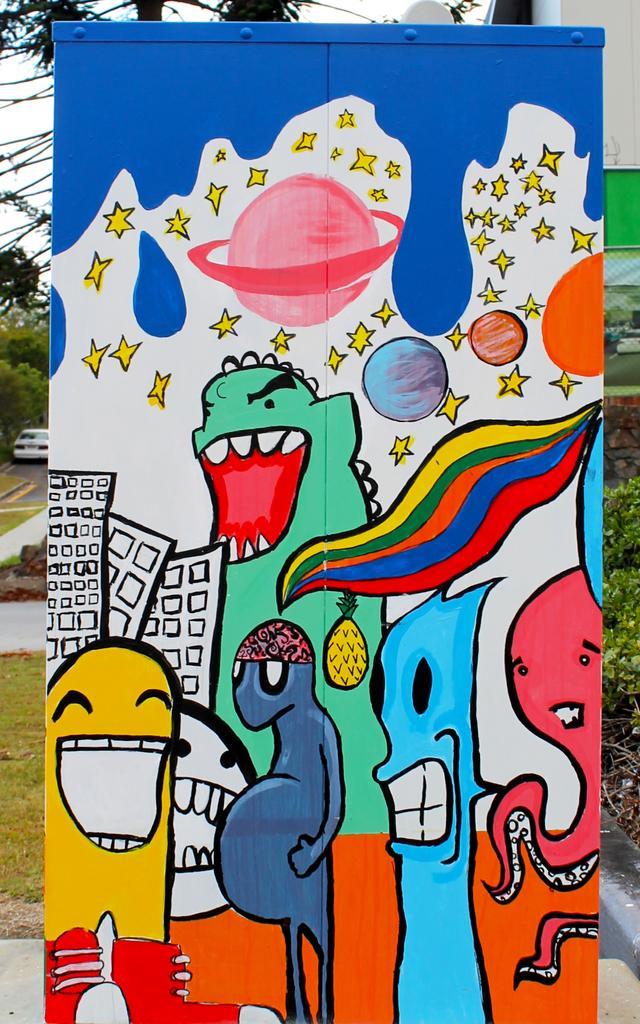How would you summarize this image in a sentence or two? In this image there is a banner with some painting on it, behind the banner there is a building, trees, a car parked on the road, grass and plants. 